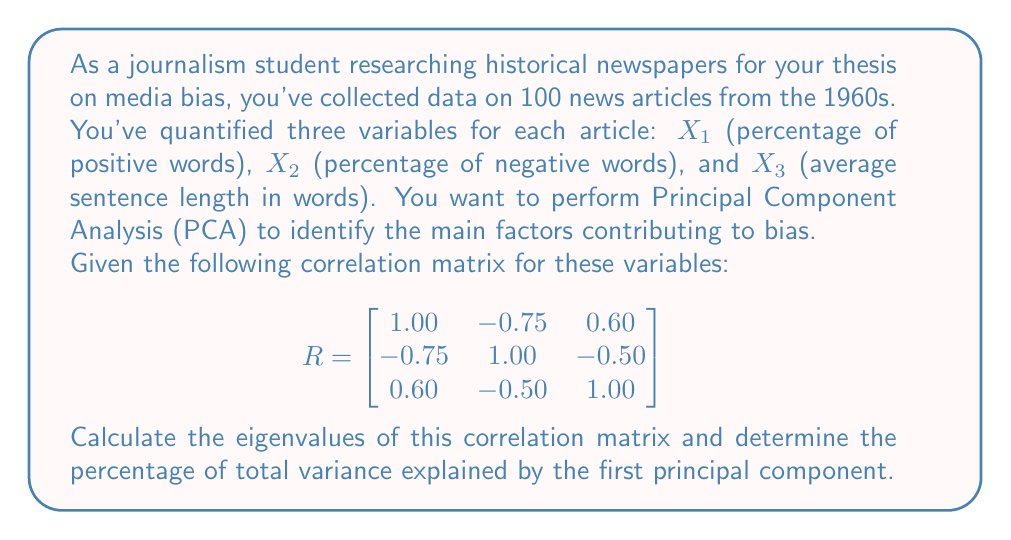Can you solve this math problem? To solve this problem, we'll follow these steps:

1) First, we need to find the eigenvalues of the correlation matrix R. The characteristic equation is:

   $$det(R - \lambda I) = 0$$

2) Expanding this determinant:

   $$\begin{vmatrix}
   1-\lambda & -0.75 & 0.60 \\
   -0.75 & 1-\lambda & -0.50 \\
   0.60 & -0.50 & 1-\lambda
   \end{vmatrix} = 0$$

3) This expands to the cubic equation:

   $$-\lambda^3 + 3\lambda^2 - 0.7625\lambda - 0.4375 = 0$$

4) Solving this equation (using a calculator or computer algebra system) gives us the eigenvalues:

   $$\lambda_1 \approx 2.3106, \lambda_2 \approx 0.5456, \lambda_3 \approx 0.1438$$

5) In PCA, the eigenvalues represent the variance explained by each principal component. The total variance is the sum of the eigenvalues:

   $$\text{Total Variance} = 2.3106 + 0.5456 + 0.1438 = 3$$

   Note: The total variance is always equal to the number of variables in a correlation matrix.

6) The percentage of total variance explained by the first principal component is:

   $$\frac{\lambda_1}{\text{Total Variance}} \times 100\% = \frac{2.3106}{3} \times 100\% \approx 77.02\%$$

Therefore, the first principal component explains approximately 77.02% of the total variance in the data.
Answer: 77.02% 